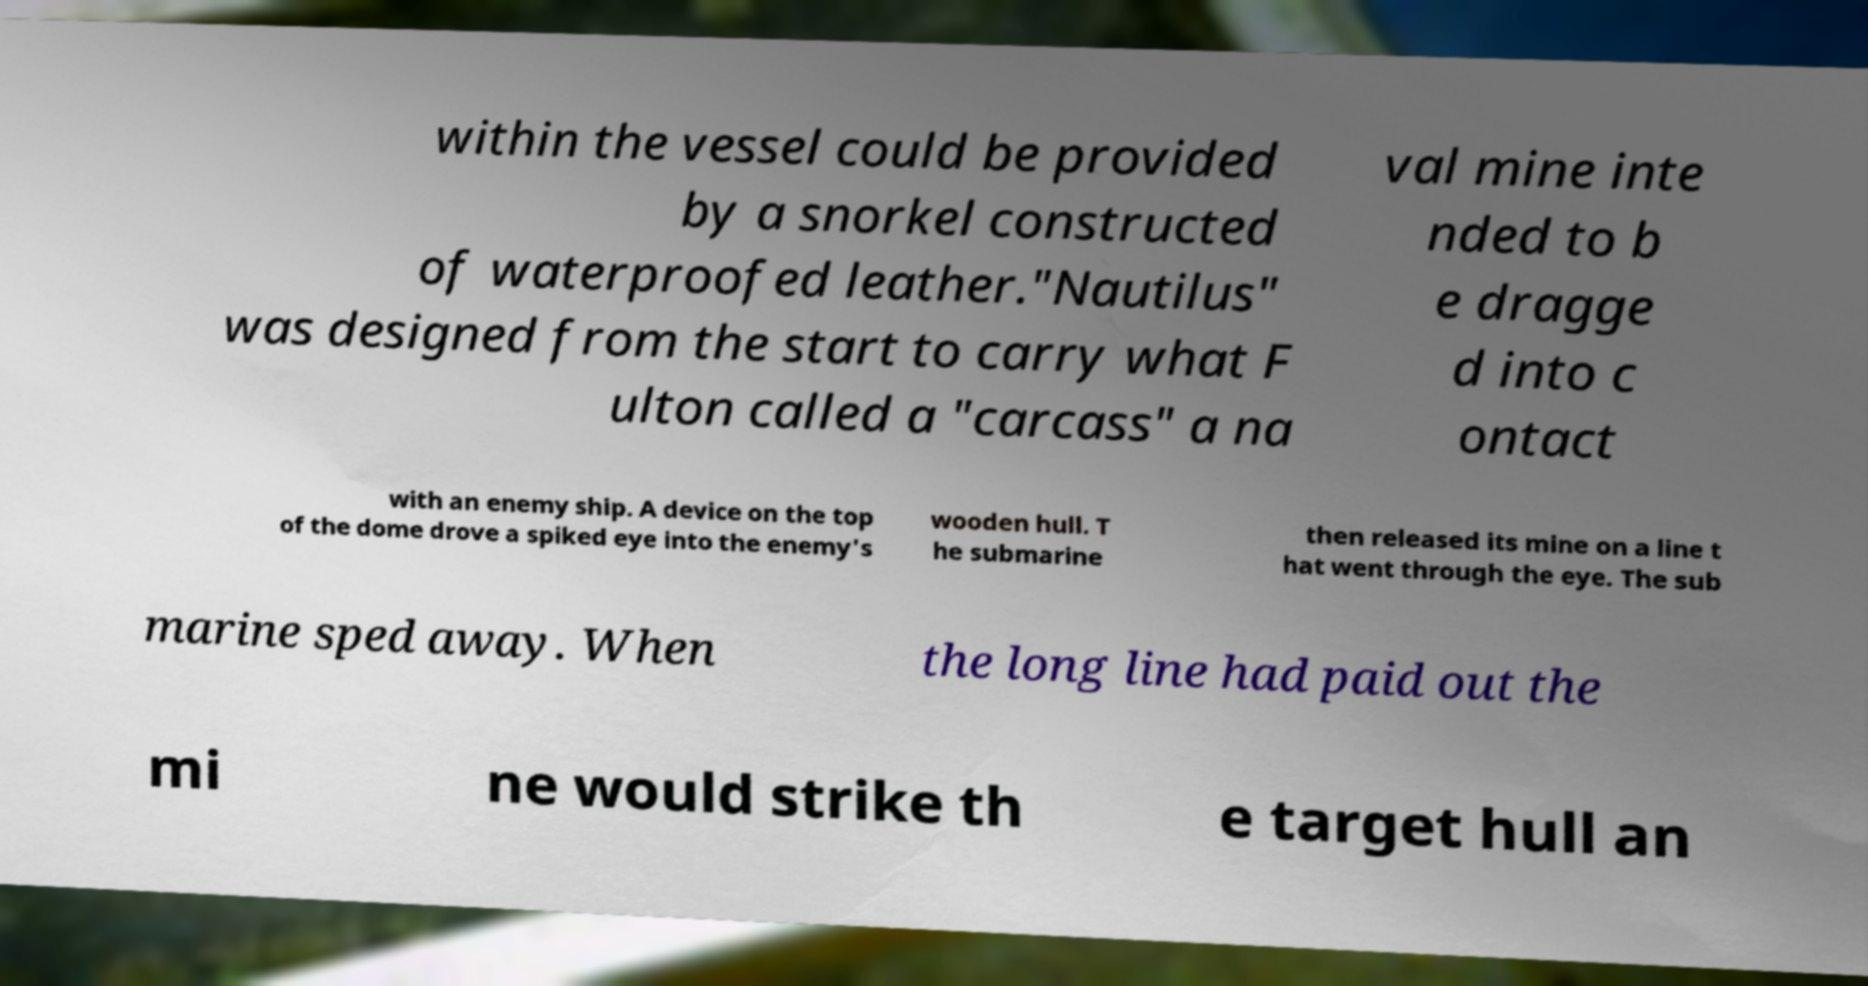Could you extract and type out the text from this image? within the vessel could be provided by a snorkel constructed of waterproofed leather."Nautilus" was designed from the start to carry what F ulton called a "carcass" a na val mine inte nded to b e dragge d into c ontact with an enemy ship. A device on the top of the dome drove a spiked eye into the enemy's wooden hull. T he submarine then released its mine on a line t hat went through the eye. The sub marine sped away. When the long line had paid out the mi ne would strike th e target hull an 